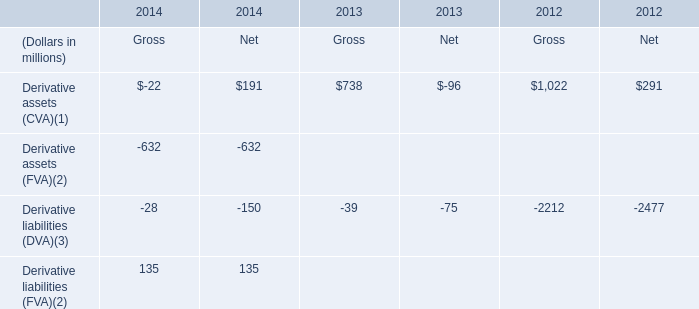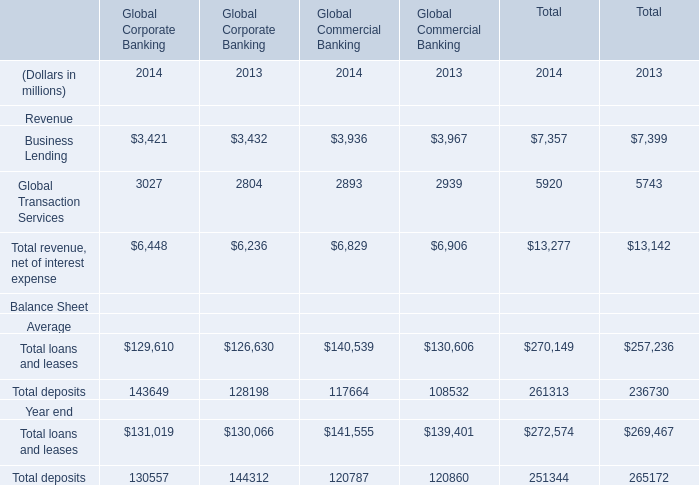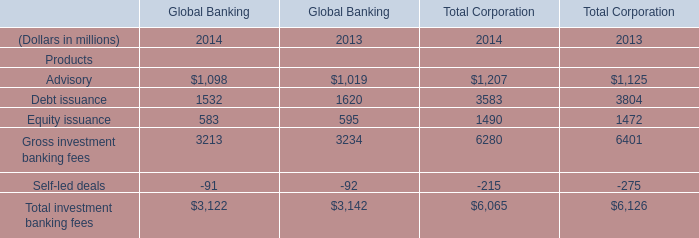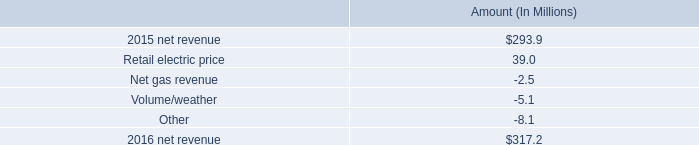In the year with lowest amount of Advisory, what's the amount of Debt issuance and Equity issuance for Global Banking? (in million) 
Computations: (1620 + 595)
Answer: 2215.0. 